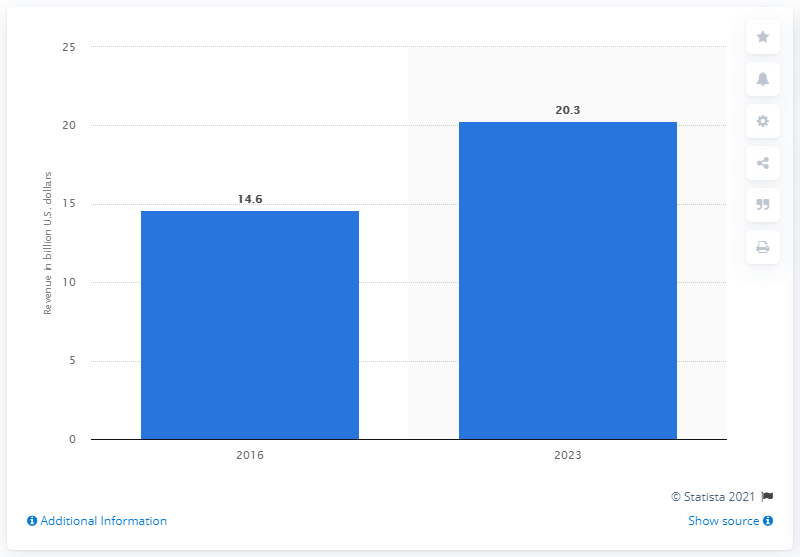Specify some key components in this picture. The global pacemaker and implantable cardioverter defibrillators market is forecasted to reach its peak in the year 2023. It is estimated that by the year 2023, the pacemaker and implantable cardioverter defibrillators market will generate revenues of approximately 20 billion U.S. dollars. 